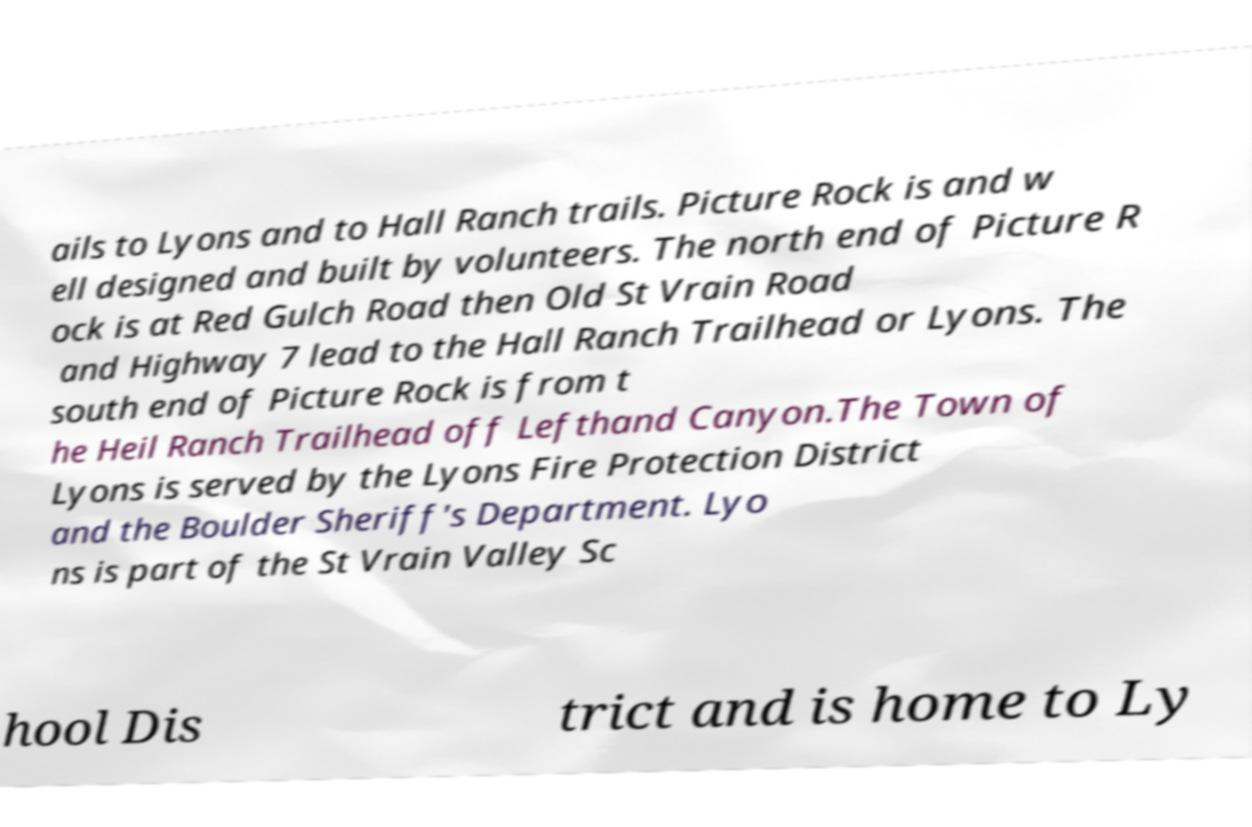There's text embedded in this image that I need extracted. Can you transcribe it verbatim? ails to Lyons and to Hall Ranch trails. Picture Rock is and w ell designed and built by volunteers. The north end of Picture R ock is at Red Gulch Road then Old St Vrain Road and Highway 7 lead to the Hall Ranch Trailhead or Lyons. The south end of Picture Rock is from t he Heil Ranch Trailhead off Lefthand Canyon.The Town of Lyons is served by the Lyons Fire Protection District and the Boulder Sheriff's Department. Lyo ns is part of the St Vrain Valley Sc hool Dis trict and is home to Ly 